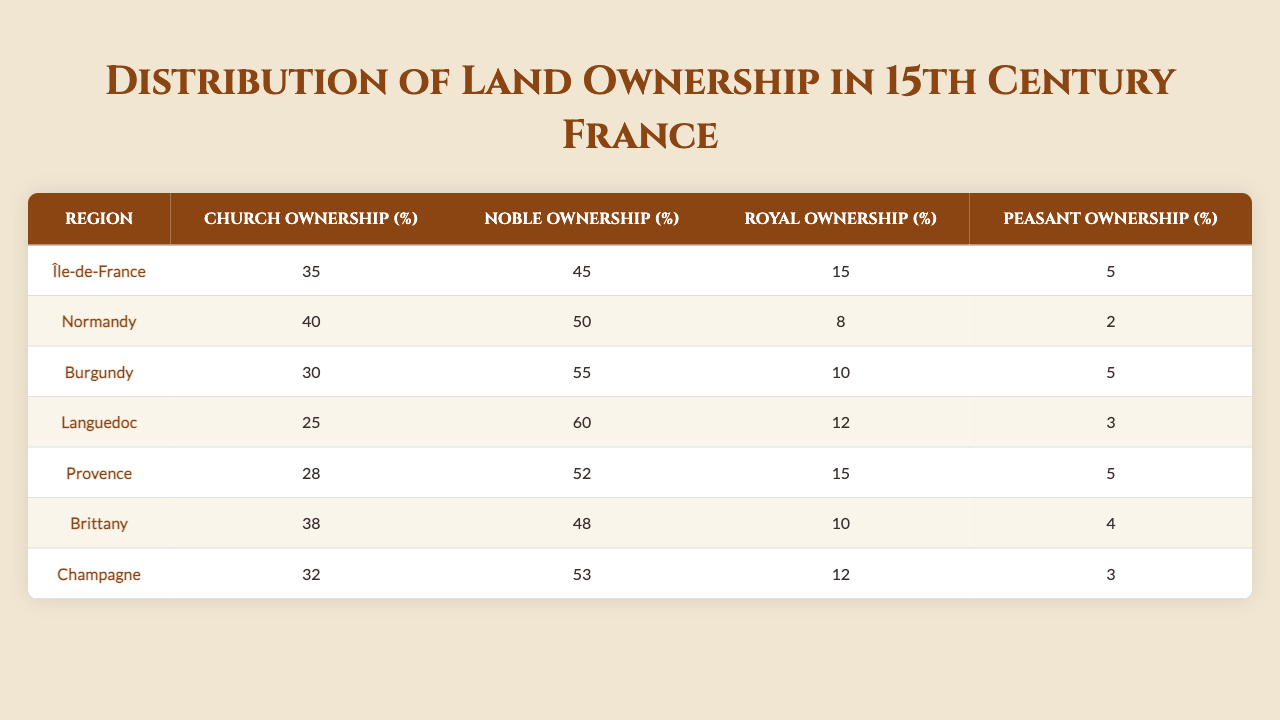What percentage of land in Normandy is owned by the Church? The table shows that Church Ownership in Normandy is 40%.
Answer: 40% In which region is Noble Ownership the highest? According to the data in the table, Languedoc has the highest Noble Ownership at 60%.
Answer: Languedoc What is the difference in Church Ownership between Île-de-France and Burgundy? Church Ownership in Île-de-France is 35% and in Burgundy is 30%. The difference is 35% - 30% = 5%.
Answer: 5% Is there more Royal Ownership in Champagne than in Provence? Champagne has 12% Royal Ownership, while Provence has 15%. As 12% is less than 15%, the answer is no.
Answer: No What is the average percentage of Church Ownership across all the regions listed? The Church Ownership percentages are 35, 40, 30, 25, 28, 38, and 32. Summing them gives 35 + 40 + 30 + 25 + 28 + 38 + 32 = 228. There are 7 regions, so the average is 228 / 7 = 32.57%.
Answer: 32.57% In which region do peasants own the least amount of land? The table indicates that Peasant Ownership is lowest in Normandy at 2%.
Answer: Normandy How much more land do nobles own than peasants in Burgundy? In Burgundy, Noble Ownership is 55% and Peasant Ownership is 5%. The difference is 55% - 5% = 50%.
Answer: 50% Is Church Ownership consistently below 40% for the regions listed? By reviewing the percentages, we find that only Champagne, Île-de-France, and Burgundy have Church Ownership below 40%, so the answer is yes, most of them are above.
Answer: No In terms of land ownership, which region has the largest disparity between Noble and Royal Ownership? The difference in Noble and Royal Ownership for each region can be calculated: Île-de-France (30%), Normandy (42%), Burgundy (45%), Languedoc (48%), Provence (37%), Brittany (38%), and Champagne (41%). Normandy shows the greatest difference of 42%.
Answer: Normandy What percentage of total land ownership was held by Nobility across all regions? Summing the Noble Ownership percentages gives 45 + 50 + 55 + 60 + 52 + 48 + 53 = 363. The average percentage across 7 regions is 363 / 7 = 51.86%.
Answer: 51.86% 